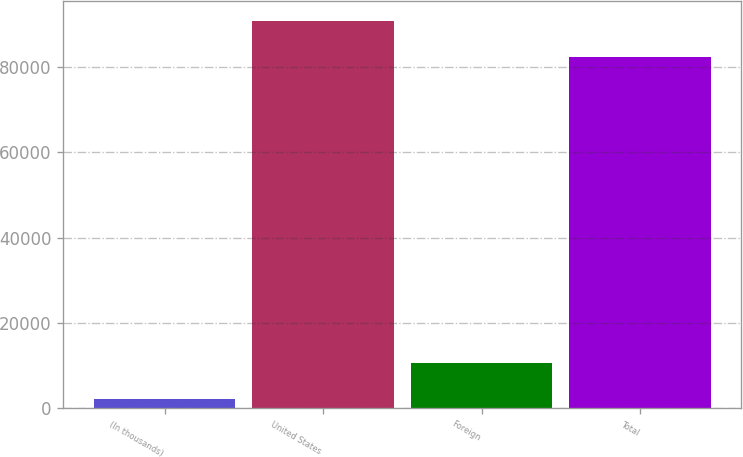<chart> <loc_0><loc_0><loc_500><loc_500><bar_chart><fcel>(In thousands)<fcel>United States<fcel>Foreign<fcel>Total<nl><fcel>2009<fcel>90892.3<fcel>10483.3<fcel>82418<nl></chart> 